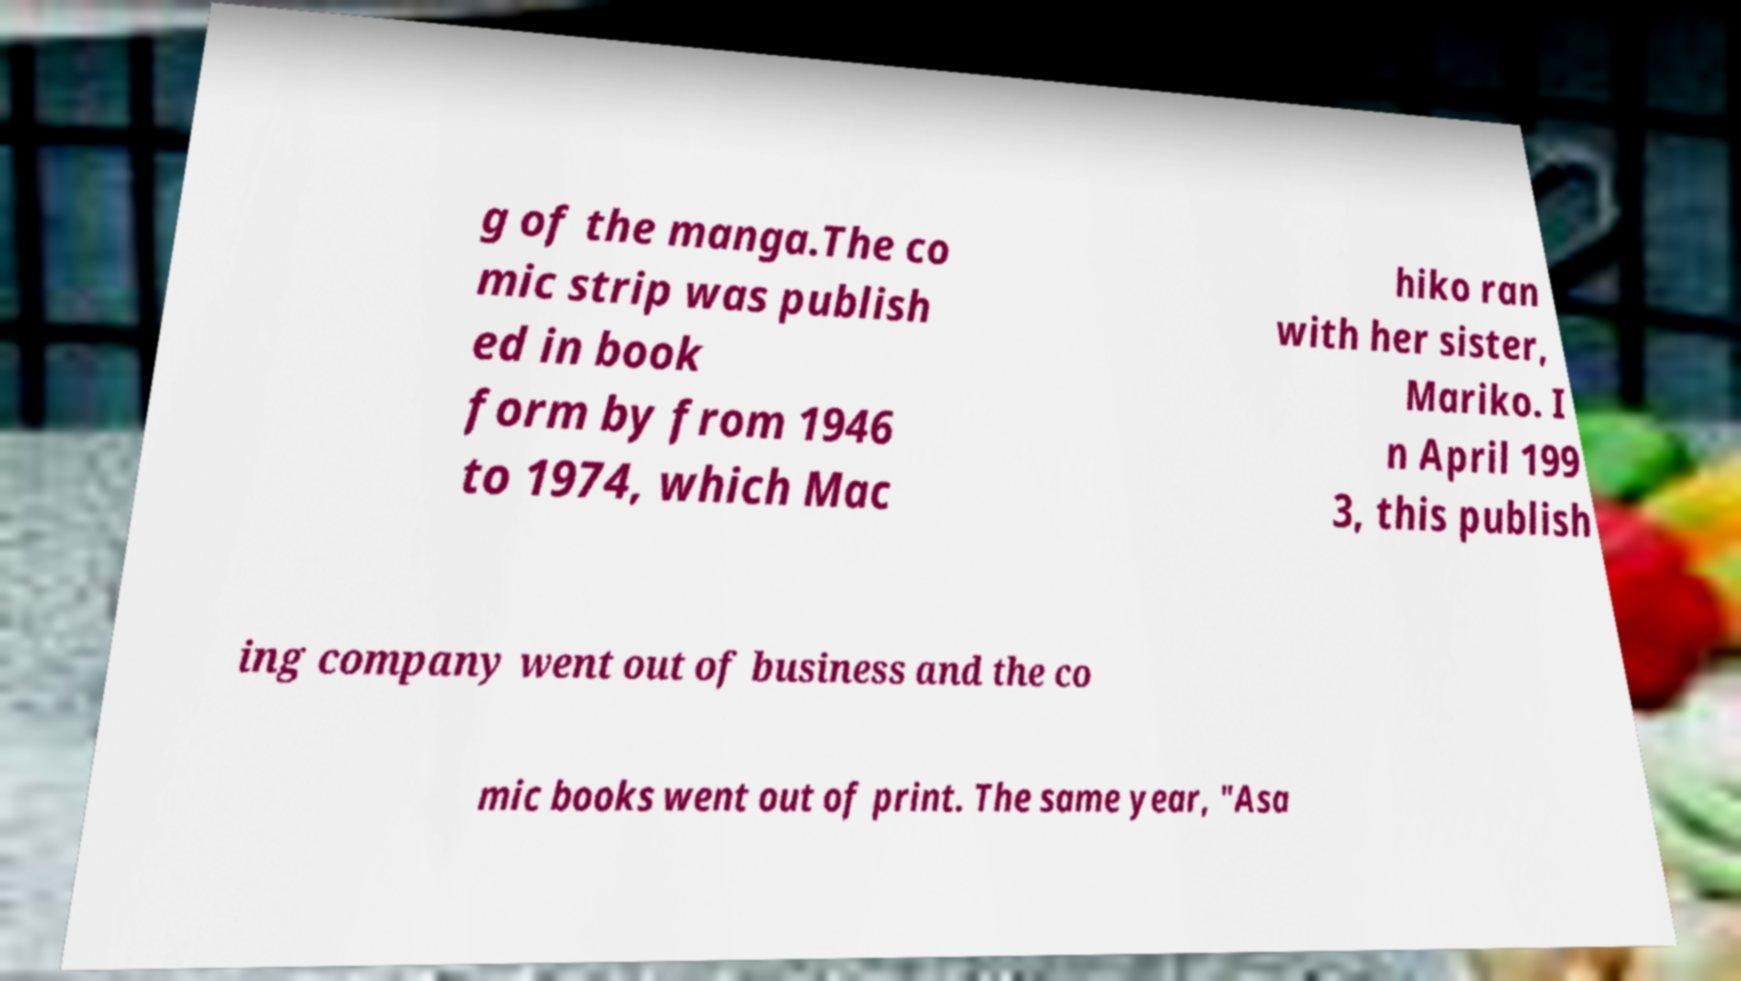Could you extract and type out the text from this image? g of the manga.The co mic strip was publish ed in book form by from 1946 to 1974, which Mac hiko ran with her sister, Mariko. I n April 199 3, this publish ing company went out of business and the co mic books went out of print. The same year, "Asa 